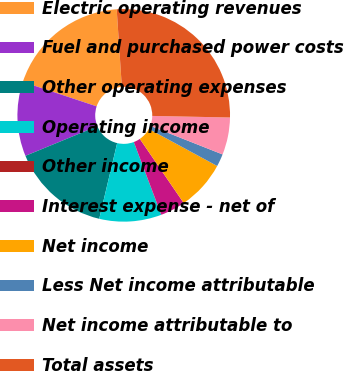Convert chart to OTSL. <chart><loc_0><loc_0><loc_500><loc_500><pie_chart><fcel>Electric operating revenues<fcel>Fuel and purchased power costs<fcel>Other operating expenses<fcel>Operating income<fcel>Other income<fcel>Interest expense - net of<fcel>Net income<fcel>Less Net income attributable<fcel>Net income attributable to<fcel>Total assets<nl><fcel>18.85%<fcel>11.32%<fcel>15.08%<fcel>9.44%<fcel>0.02%<fcel>3.79%<fcel>7.55%<fcel>1.91%<fcel>5.67%<fcel>26.38%<nl></chart> 